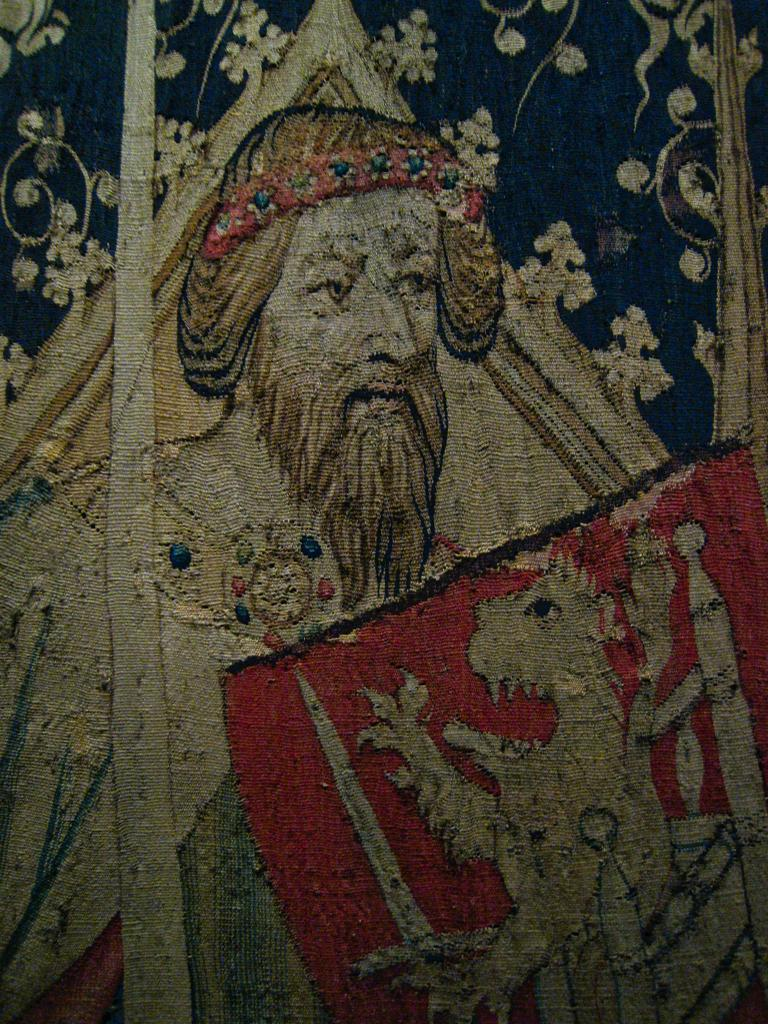What types of images are present in the image? There are pictures of a person and an animal in the image. Where are the pictures located? The pictures are on a cloth. What type of flower is depicted in the image? There is no flower present in the image; it features pictures of a person and an animal on a cloth. 